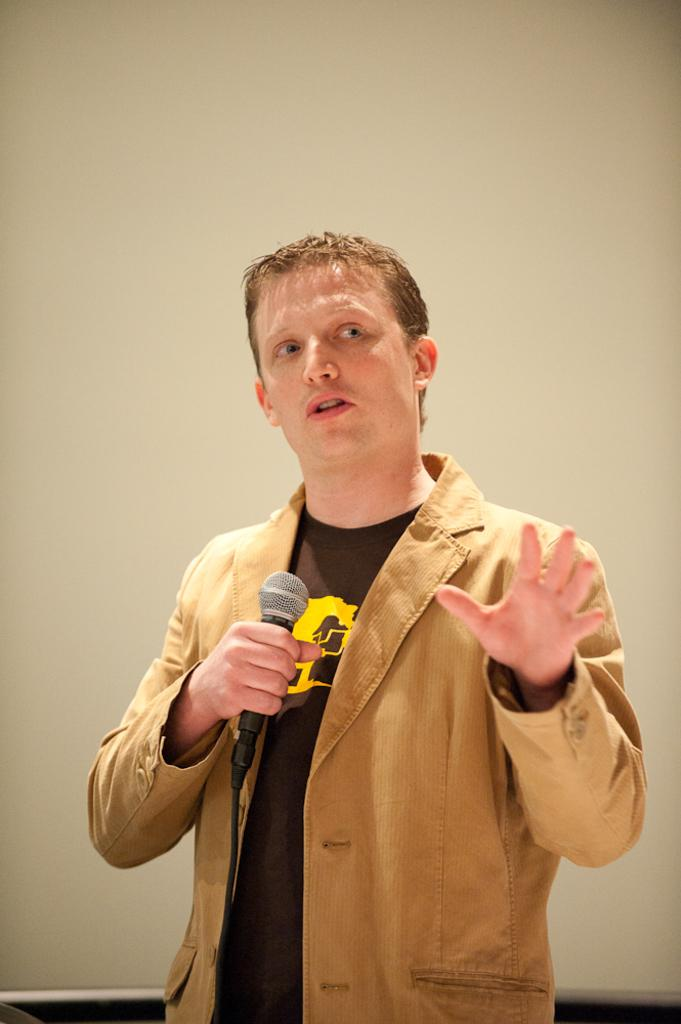What is the main subject of the image? There is a man in the image. What is the man holding in his hand? The man is holding a microphone in his hand. What can be seen in the background of the image? There is a wall in the background of the image. What type of rake is the man using to gather leaves in the image? There is no rake present in the image; the man is holding a microphone. Can you tell me how many yaks are visible in the image? There are no yaks present in the image. 